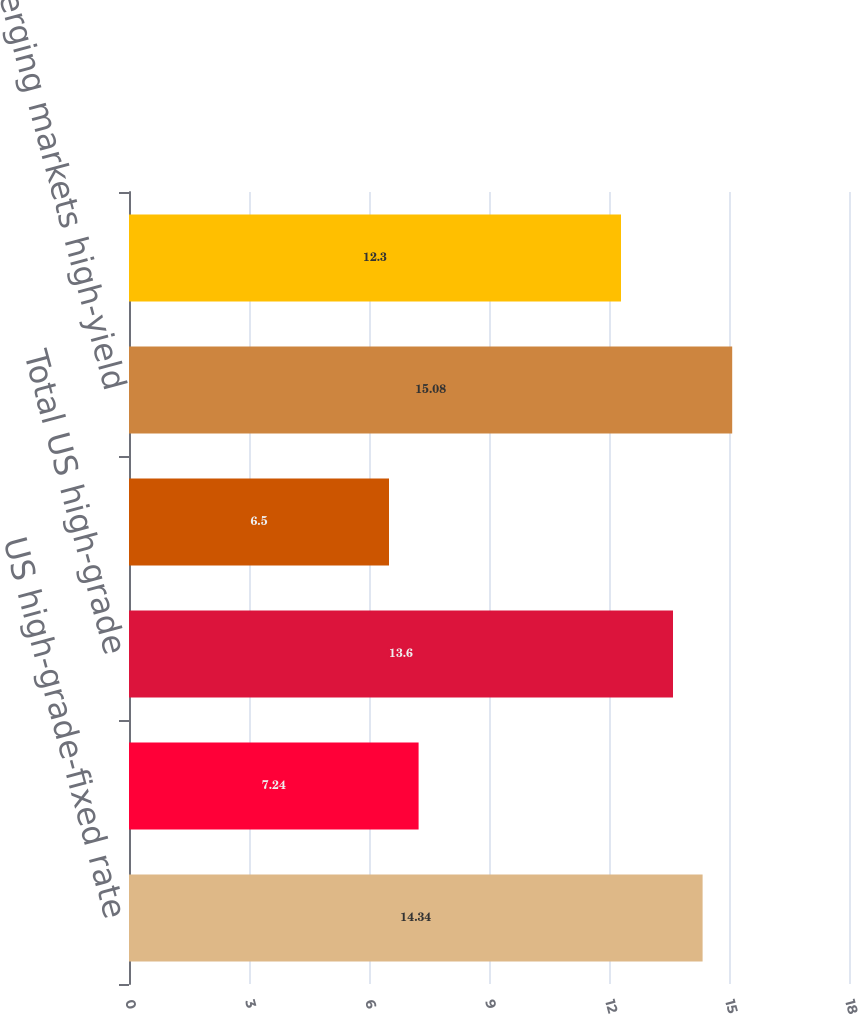<chart> <loc_0><loc_0><loc_500><loc_500><bar_chart><fcel>US high-grade-fixed rate<fcel>US high-grade-floating rate<fcel>Total US high-grade<fcel>Eurobond<fcel>Emerging markets high-yield<fcel>Total<nl><fcel>14.34<fcel>7.24<fcel>13.6<fcel>6.5<fcel>15.08<fcel>12.3<nl></chart> 